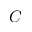<formula> <loc_0><loc_0><loc_500><loc_500>C</formula> 